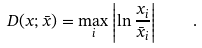Convert formula to latex. <formula><loc_0><loc_0><loc_500><loc_500>D ( x ; \bar { x } ) = \max _ { i } \left | \ln \frac { x _ { i } } { \bar { x } _ { i } } \right | \quad .</formula> 